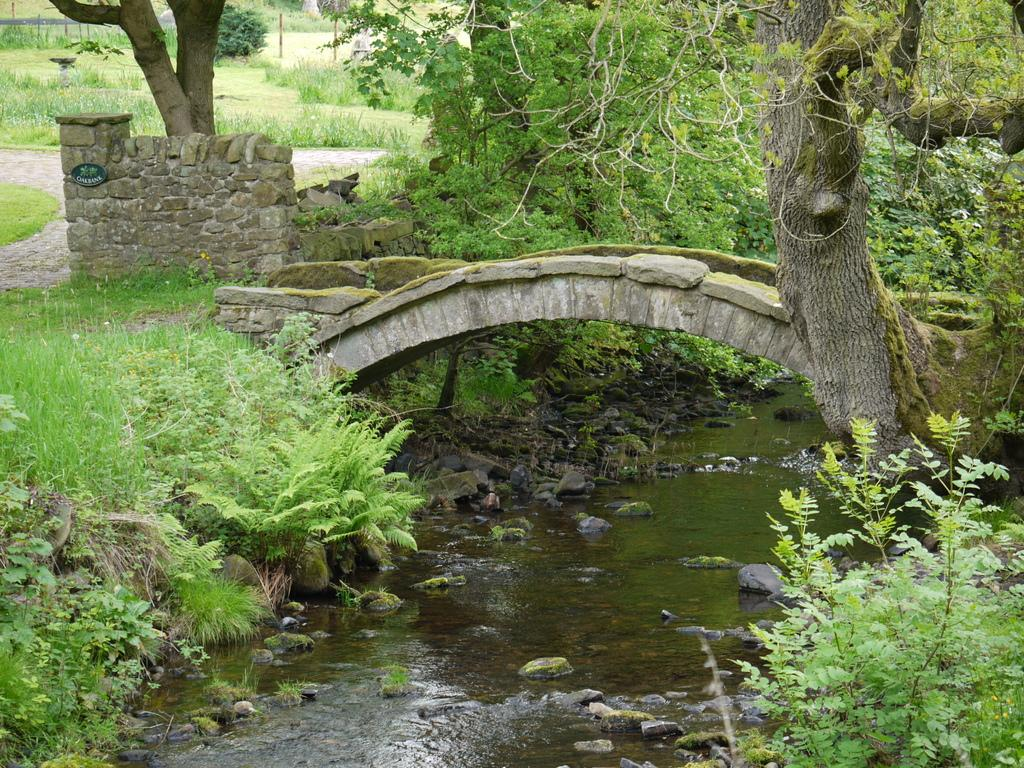What type of vegetation is present on both sides of the image? There is grass on both the left and right sides of the image. What structure can be seen in the middle of the image? There is a bridge in the middle of the image. What is visible in the image besides the grass and bridge? There is water visible in the image. What can be seen in the background of the image? There are trees in the background of the image. What type of pump is used to burn things in the image? There is no pump or burning activity present in the image. What things are being burned in the image? There are no things being burned in the image. 